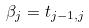<formula> <loc_0><loc_0><loc_500><loc_500>\beta _ { j } = t _ { j - 1 , j }</formula> 